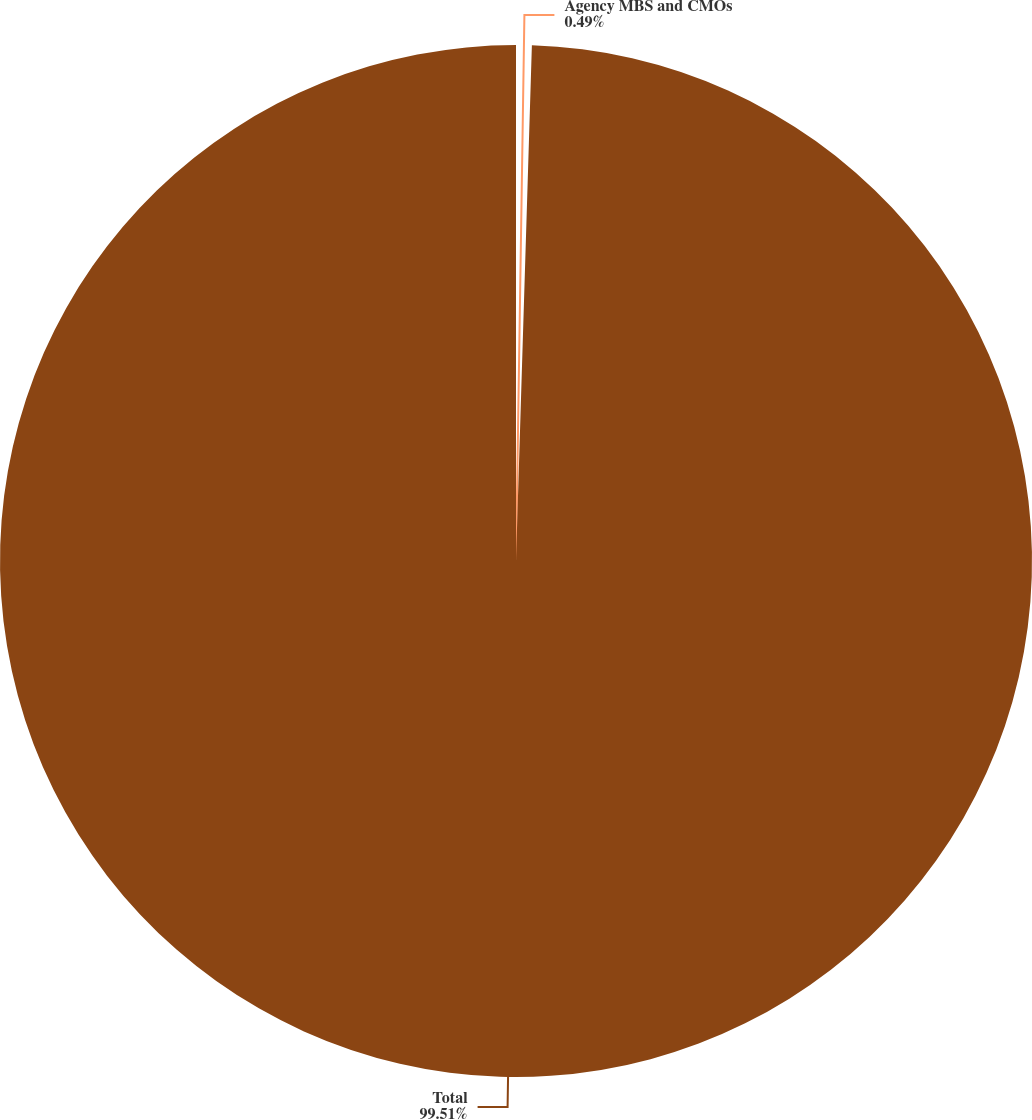<chart> <loc_0><loc_0><loc_500><loc_500><pie_chart><fcel>Agency MBS and CMOs<fcel>Total<nl><fcel>0.49%<fcel>99.51%<nl></chart> 